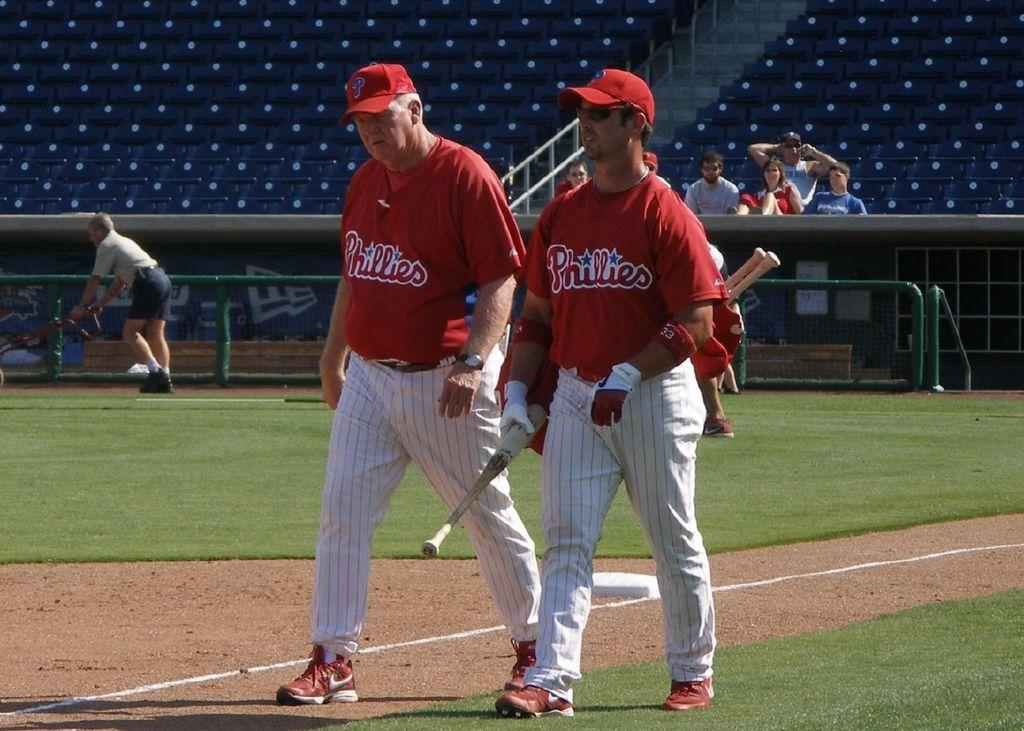<image>
Create a compact narrative representing the image presented. Two guys in Phillies uniforms are on a baseball field. 